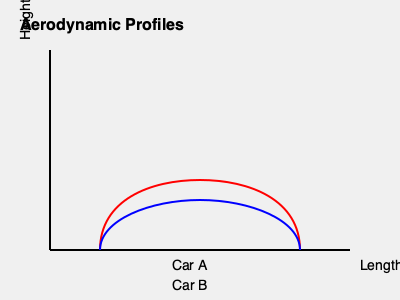Based on the aerodynamic profiles of two subcompact cars shown above, which car is likely to have better fuel efficiency, and why? To determine which car is likely to have better fuel efficiency based on their aerodynamic profiles, we need to consider the following steps:

1. Analyze the shape: 
   - Car A (red) has a more curved and streamlined profile.
   - Car B (blue) has a flatter, less curved profile.

2. Understand aerodynamics:
   - A more streamlined shape reduces air resistance (drag).
   - Lower drag leads to better fuel efficiency.

3. Compare the profiles:
   - Car A's profile creates less air resistance due to its smoother curve.
   - Car B's flatter profile will create more air resistance.

4. Consider the coefficient of drag ($C_d$):
   - The $C_d$ is lower for more streamlined shapes.
   - A lower $C_d$ results in less energy needed to overcome air resistance.

5. Relate to fuel efficiency:
   - Less energy needed to overcome air resistance means better fuel efficiency.
   - The formula for drag force is: $F_d = \frac{1}{2} \rho v^2 C_d A$
     Where $\rho$ is air density, $v$ is velocity, $C_d$ is drag coefficient, and $A$ is frontal area.

6. Conclusion:
   - Car A, with its more streamlined profile, will likely have a lower $C_d$.
   - This lower $C_d$ translates to less drag force at the same speed.
   - Less drag force means the engine doesn't need to work as hard, resulting in better fuel efficiency.

Therefore, Car A is likely to have better fuel efficiency due to its more aerodynamic profile.
Answer: Car A, due to its more streamlined profile resulting in lower air resistance. 